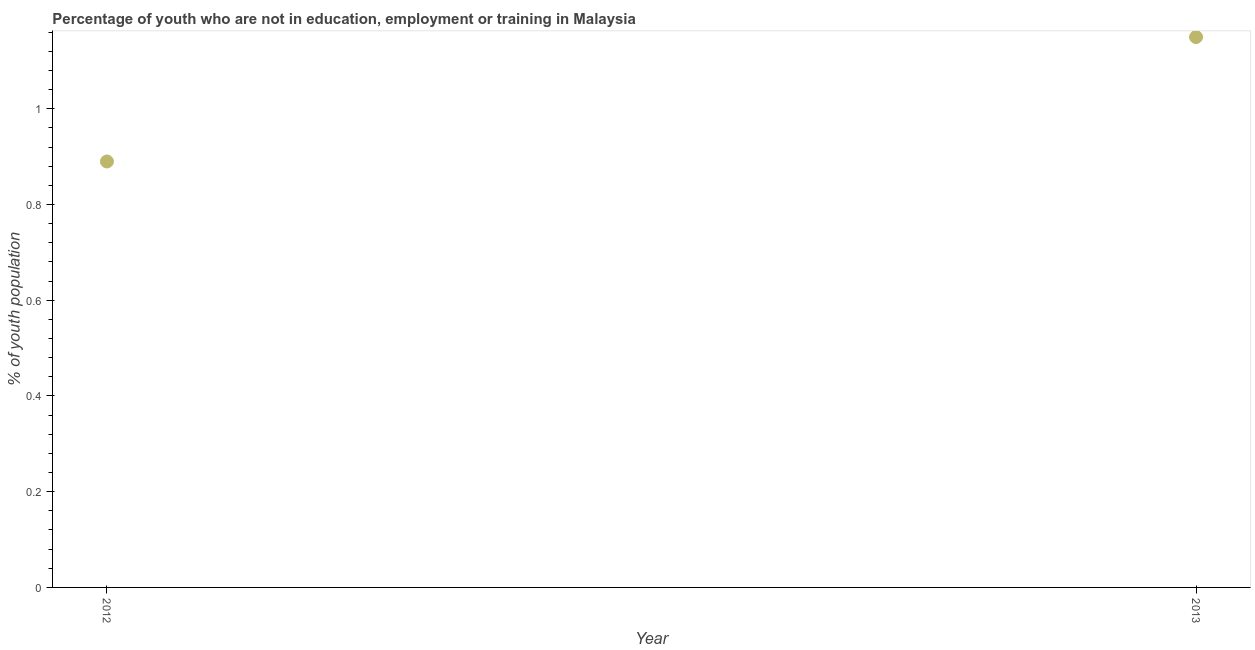What is the unemployed youth population in 2013?
Your answer should be very brief. 1.15. Across all years, what is the maximum unemployed youth population?
Give a very brief answer. 1.15. Across all years, what is the minimum unemployed youth population?
Keep it short and to the point. 0.89. In which year was the unemployed youth population maximum?
Offer a terse response. 2013. What is the sum of the unemployed youth population?
Provide a succinct answer. 2.04. What is the difference between the unemployed youth population in 2012 and 2013?
Give a very brief answer. -0.26. What is the average unemployed youth population per year?
Give a very brief answer. 1.02. What is the median unemployed youth population?
Provide a short and direct response. 1.02. In how many years, is the unemployed youth population greater than 0.12 %?
Give a very brief answer. 2. Do a majority of the years between 2012 and 2013 (inclusive) have unemployed youth population greater than 0.44 %?
Offer a terse response. Yes. What is the ratio of the unemployed youth population in 2012 to that in 2013?
Provide a succinct answer. 0.77. Is the unemployed youth population in 2012 less than that in 2013?
Ensure brevity in your answer.  Yes. In how many years, is the unemployed youth population greater than the average unemployed youth population taken over all years?
Offer a very short reply. 1. How many dotlines are there?
Offer a very short reply. 1. What is the difference between two consecutive major ticks on the Y-axis?
Your response must be concise. 0.2. Are the values on the major ticks of Y-axis written in scientific E-notation?
Your answer should be very brief. No. Does the graph contain any zero values?
Offer a very short reply. No. What is the title of the graph?
Your answer should be very brief. Percentage of youth who are not in education, employment or training in Malaysia. What is the label or title of the X-axis?
Your answer should be compact. Year. What is the label or title of the Y-axis?
Ensure brevity in your answer.  % of youth population. What is the % of youth population in 2012?
Keep it short and to the point. 0.89. What is the % of youth population in 2013?
Give a very brief answer. 1.15. What is the difference between the % of youth population in 2012 and 2013?
Offer a terse response. -0.26. What is the ratio of the % of youth population in 2012 to that in 2013?
Provide a succinct answer. 0.77. 